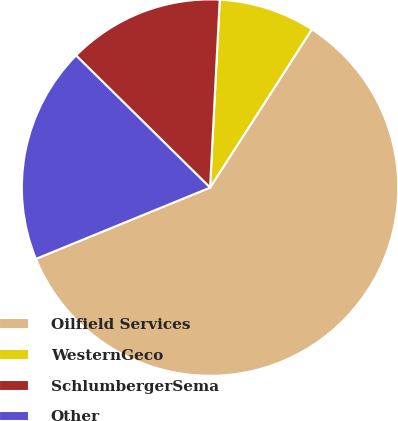Convert chart to OTSL. <chart><loc_0><loc_0><loc_500><loc_500><pie_chart><fcel>Oilfield Services<fcel>WesternGeco<fcel>SchlumbergerSema<fcel>Other<nl><fcel>59.72%<fcel>8.28%<fcel>13.43%<fcel>18.57%<nl></chart> 